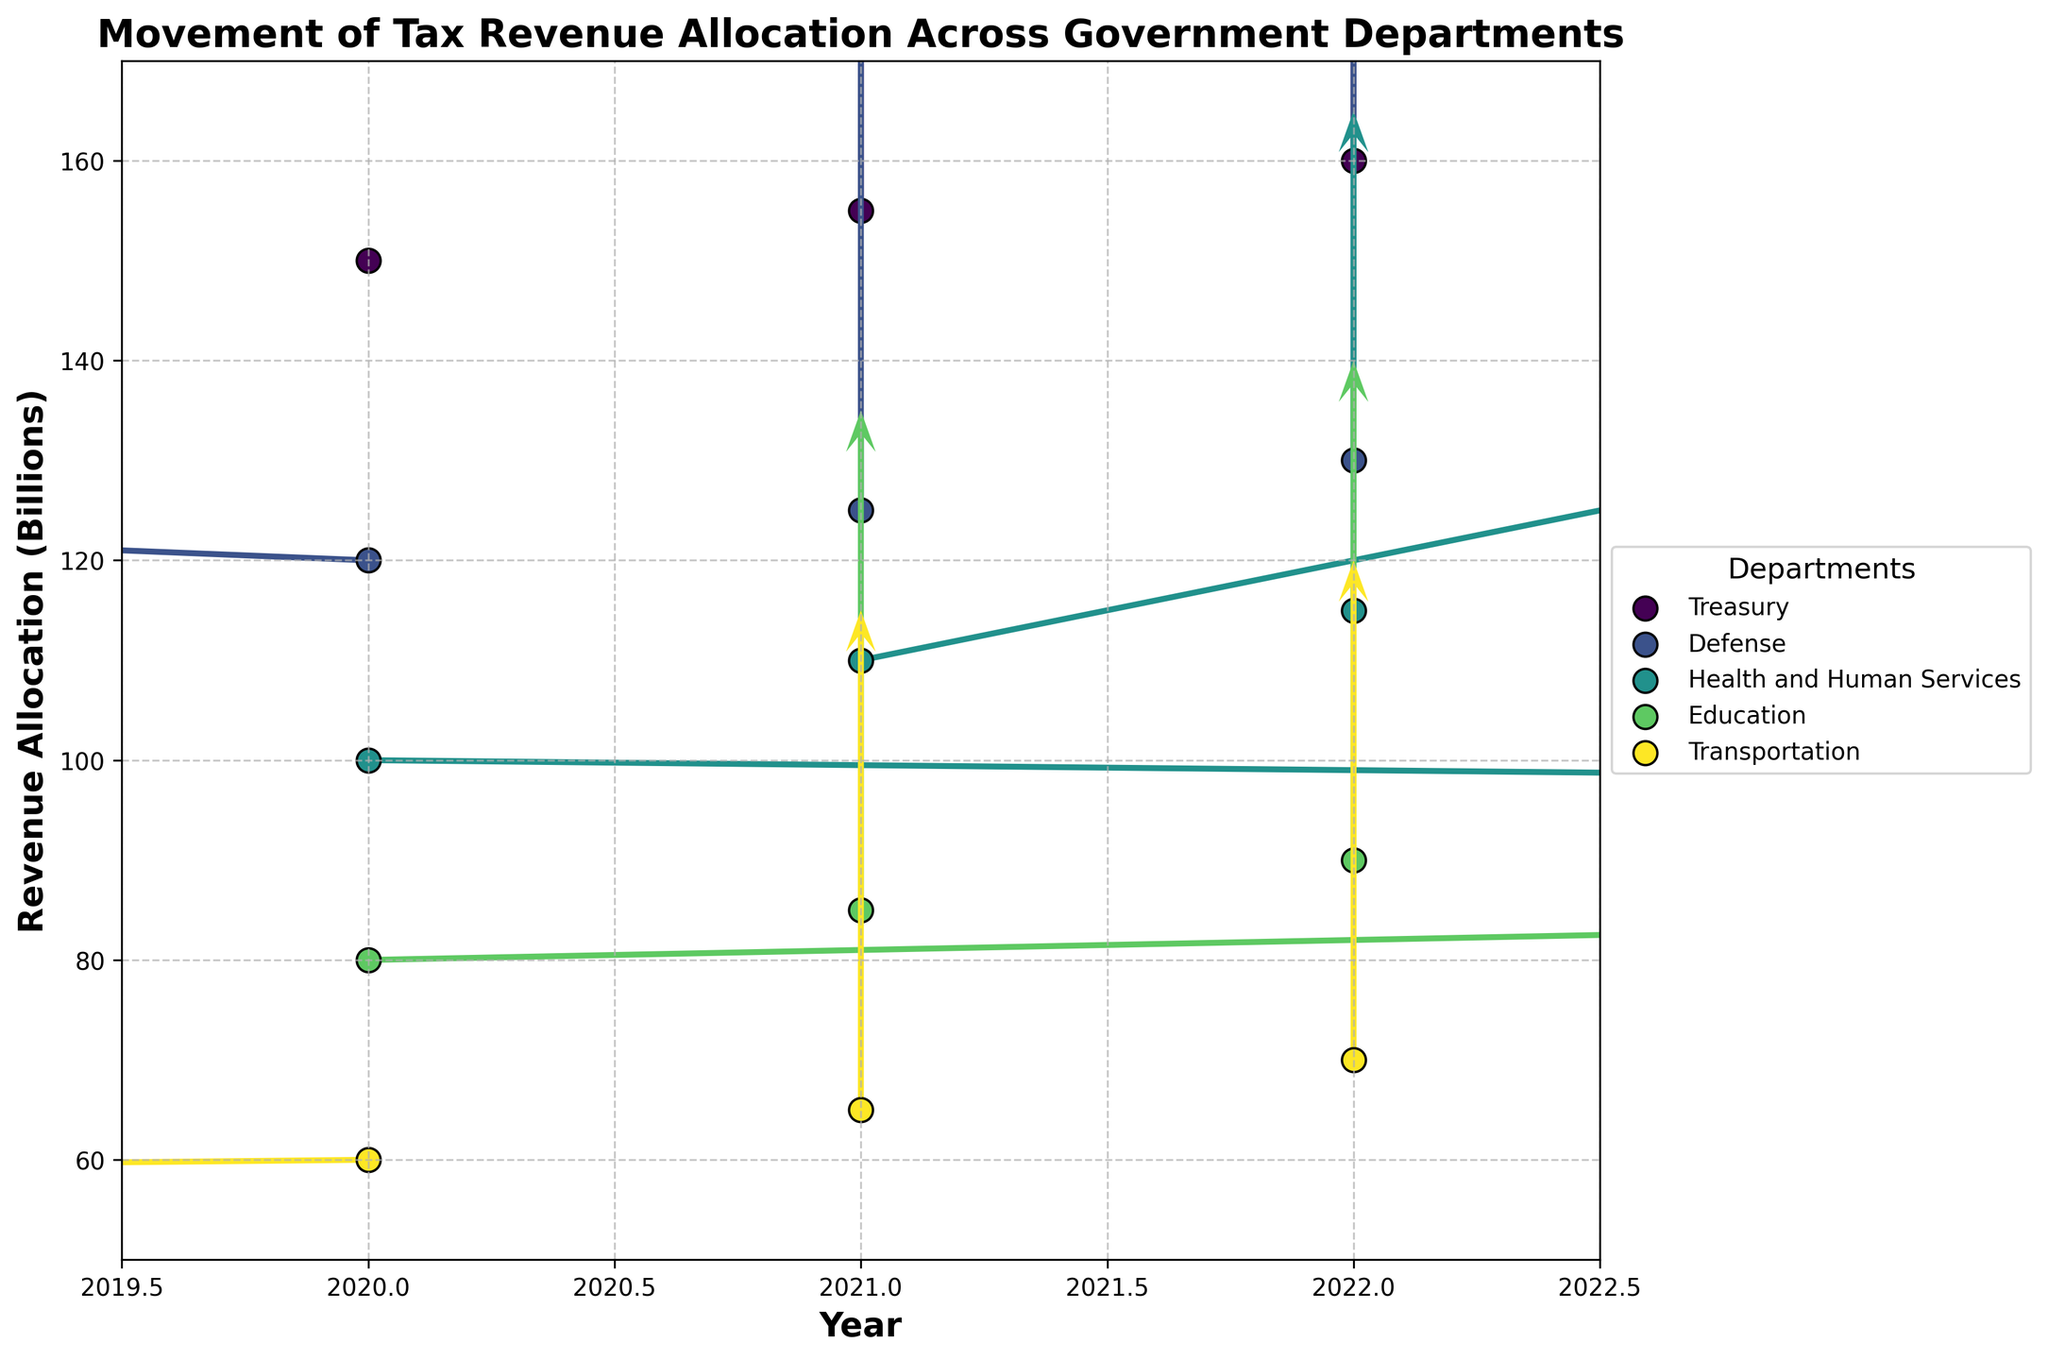What are the departments represented in the plot? The departments can be identified by the legend, which lists all the unique departments with their corresponding colors.
Answer: Treasury, Defense, Health and Human Services, Education, Transportation What is the title of the plot? The title is located at the top of the plot and describes the overall topic of the visualization.
Answer: Movement of Tax Revenue Allocation Across Government Departments What are the axes labels? The labels for the x and y axes describe the type of data each axis represents.
Answer: Year (x-axis), Revenue Allocation (Billions) (y-axis) Which department had the highest revenue allocation in 2020? By looking at the position on the y-axis for the year 2020 for each department, the highest point indicates the highest allocation.
Answer: Treasury What is the general trend of the revenue allocation for the Transportation department from 2020 to 2022? Observing the arrows and positions of the points for the Transportation department from 2020 through 2022 helps deduce the trend.
Answer: Increasing Which department showed the most significant change in revenue allocation magnitude from 2020 to 2021? The department with the longest arrow (change vector) between 2020 and 2021 indicates the most significant change.
Answer: Health and Human Services How does the growth trend of the Defense department compare to the Education department from 2020 to 2022? Compare the directions and lengths of the arrows for both departments from 2020 to 2022.
Answer: Both increase steadily, but the Defense department has a slightly higher initial allocation and consistent increments Which department has the least change in revenue allocation direction over the years? The department with vectors mostly vertical indicates the least change in the direction of revenue allocation.
Answer: Treasury What is the net change in revenue allocation for the Treasury department from 2020 to 2022? Sum the changes in allocation from 2020 to 2021 and 2021 to 2022 for the Treasury department.
Answer: +10 billion (5 billion per year) 